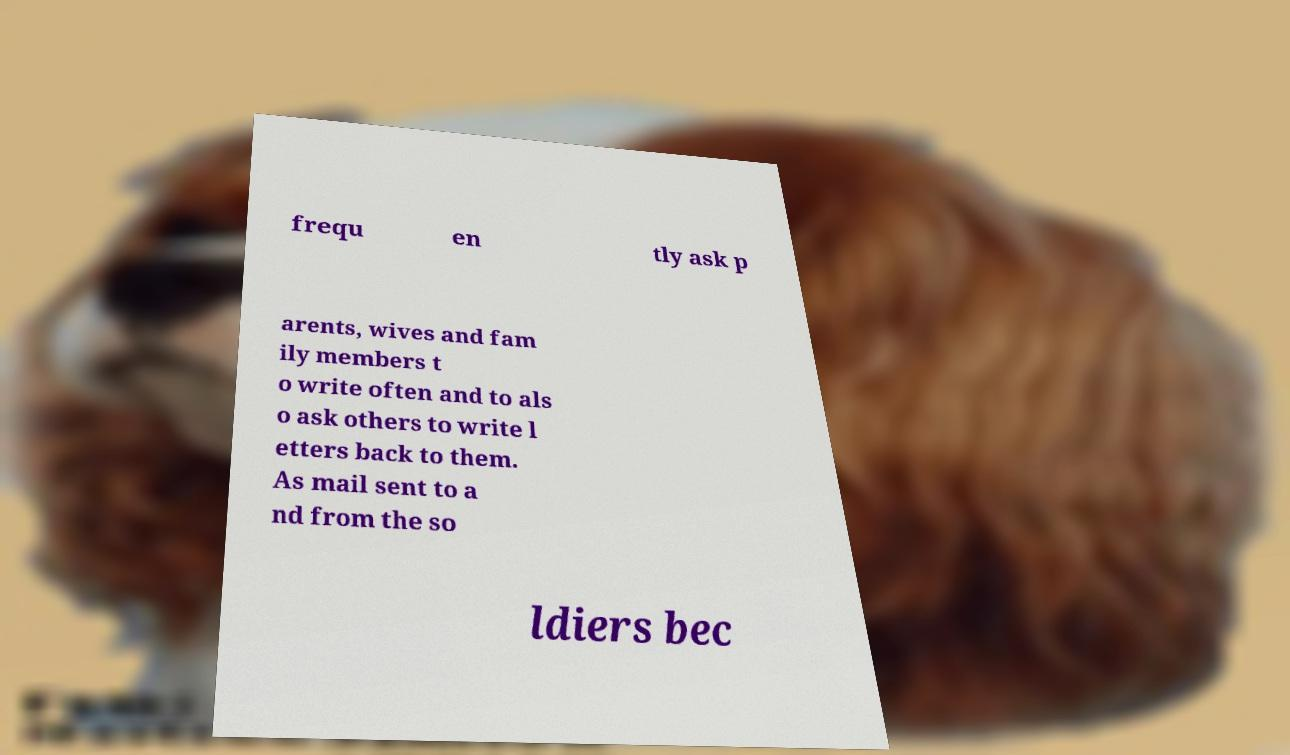Could you extract and type out the text from this image? frequ en tly ask p arents, wives and fam ily members t o write often and to als o ask others to write l etters back to them. As mail sent to a nd from the so ldiers bec 